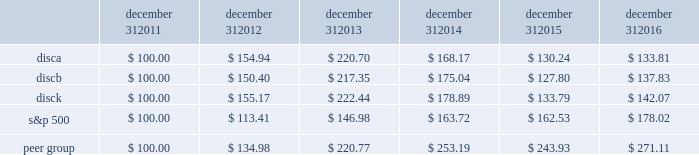December 31 , december 31 , december 31 , december 31 , december 31 , december 31 .
Equity compensation plan information information regarding securities authorized for issuance under equity compensation plans will be set forth in our definitive proxy statement for our 2017 annual meeting of stockholders under the caption 201csecurities authorized for issuance under equity compensation plans , 201d which is incorporated herein by reference .
Item 6 .
Selected financial data .
The table set forth below presents our selected financial information for each of the past five years ( in millions , except per share amounts ) .
The selected statement of operations information for each of the three years ended december 31 , 2016 and the selected balance sheet information as of december 31 , 2016 and 2015 have been derived from and should be read in conjunction with the information in item 7 , 201cmanagement 2019s discussion and analysis of financial condition and results of operations , 201d the audited consolidated financial statements included in item 8 , 201cfinancial statements and supplementary data , 201d and other financial information included elsewhere in this annual report on form 10-k .
The selected statement of operations information for each of the two years ended december 31 , 2013 and 2012 and the selected balance sheet information as of december 31 , 2014 , 2013 and 2012 have been derived from financial statements not included in this annual report on form 10-k .
2016 2015 2014 2013 2012 selected statement of operations information : revenues $ 6497 $ 6394 $ 6265 $ 5535 $ 4487 operating income 2058 1985 2061 1975 1859 income from continuing operations , net of taxes 1218 1048 1137 1077 956 loss from discontinued operations , net of taxes 2014 2014 2014 2014 ( 11 ) net income 1218 1048 1137 1077 945 net income available to discovery communications , inc .
1194 1034 1139 1075 943 basic earnings per share available to discovery communications , inc .
Series a , b and c common stockholders : continuing operations $ 1.97 $ 1.59 $ 1.67 $ 1.50 $ 1.27 discontinued operations 2014 2014 2014 2014 ( 0.01 ) net income 1.97 1.59 1.67 1.50 1.25 diluted earnings per share available to discovery communications , inc .
Series a , b and c common stockholders : continuing operations $ 1.96 $ 1.58 $ 1.66 $ 1.49 $ 1.26 discontinued operations 2014 2014 2014 2014 ( 0.01 ) net income 1.96 1.58 1.66 1.49 1.24 weighted average shares outstanding : basic 401 432 454 484 498 diluted 610 656 687 722 759 selected balance sheet information : cash and cash equivalents $ 300 $ 390 $ 367 $ 408 $ 1201 total assets 15758 15864 15970 14934 12892 long-term debt : current portion 82 119 1107 17 31 long-term portion 7841 7616 6002 6437 5174 total liabilities 10348 10172 9619 8701 6599 redeemable noncontrolling interests 243 241 747 36 2014 equity attributable to discovery communications , inc .
5167 5451 5602 6196 6291 total equity $ 5167 $ 5451 $ 5604 $ 6197 $ 6293 2022 income per share amounts may not sum since each is calculated independently .
2022 on september 30 , 2016 , the company recorded an other-than-temporary impairment of $ 62 million related to its investment in lionsgate .
On december 2 , 2016 , the company acquired a 39% ( 39 % ) minority interest in group nine media , a newly formed media holding company , in exchange for contributions of $ 100 million and the company's digital network businesses seeker and sourcefed , resulting in a gain of $ 50 million upon deconsolidation of the businesses .
( see note 4 to the accompanying consolidated financial statements. ) .
What would the company's 2016 net income be in millions without the impairment related to its investment in lionsgate? 
Computations: (62 + 1218)
Answer: 1280.0. 